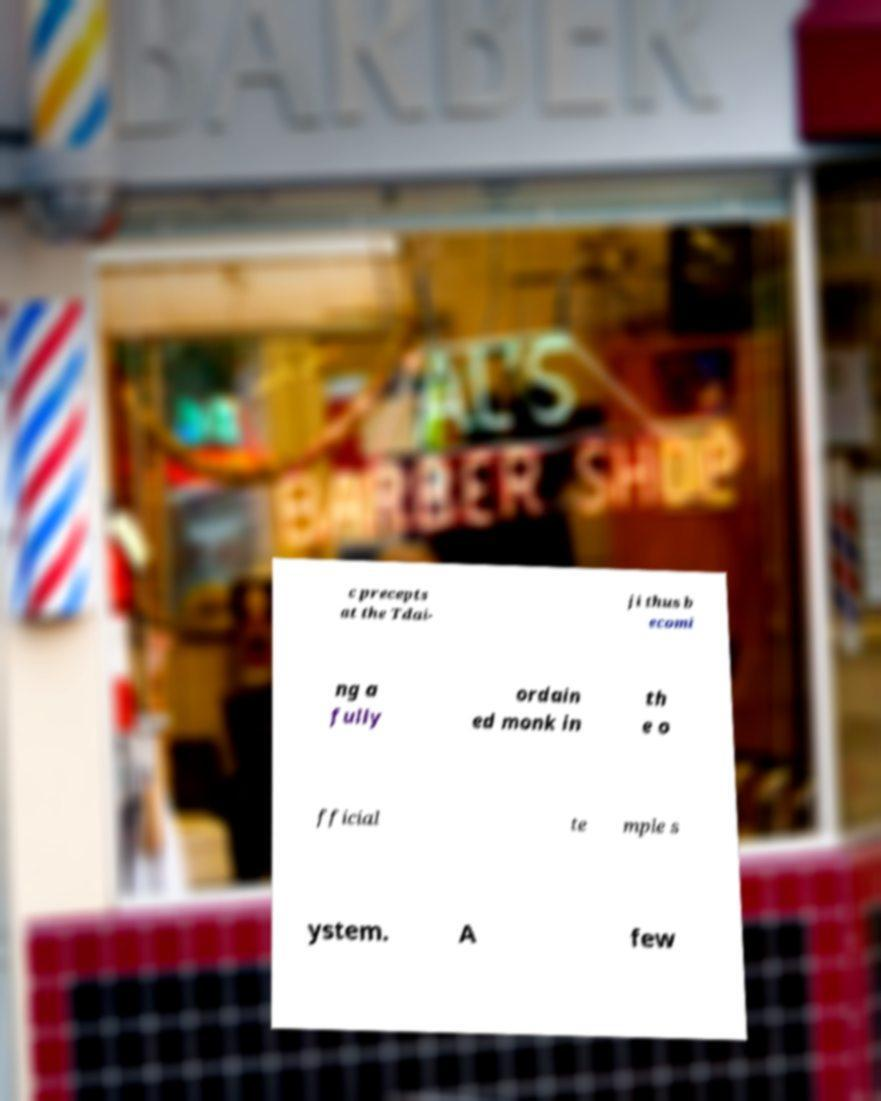Could you assist in decoding the text presented in this image and type it out clearly? c precepts at the Tdai- ji thus b ecomi ng a fully ordain ed monk in th e o fficial te mple s ystem. A few 